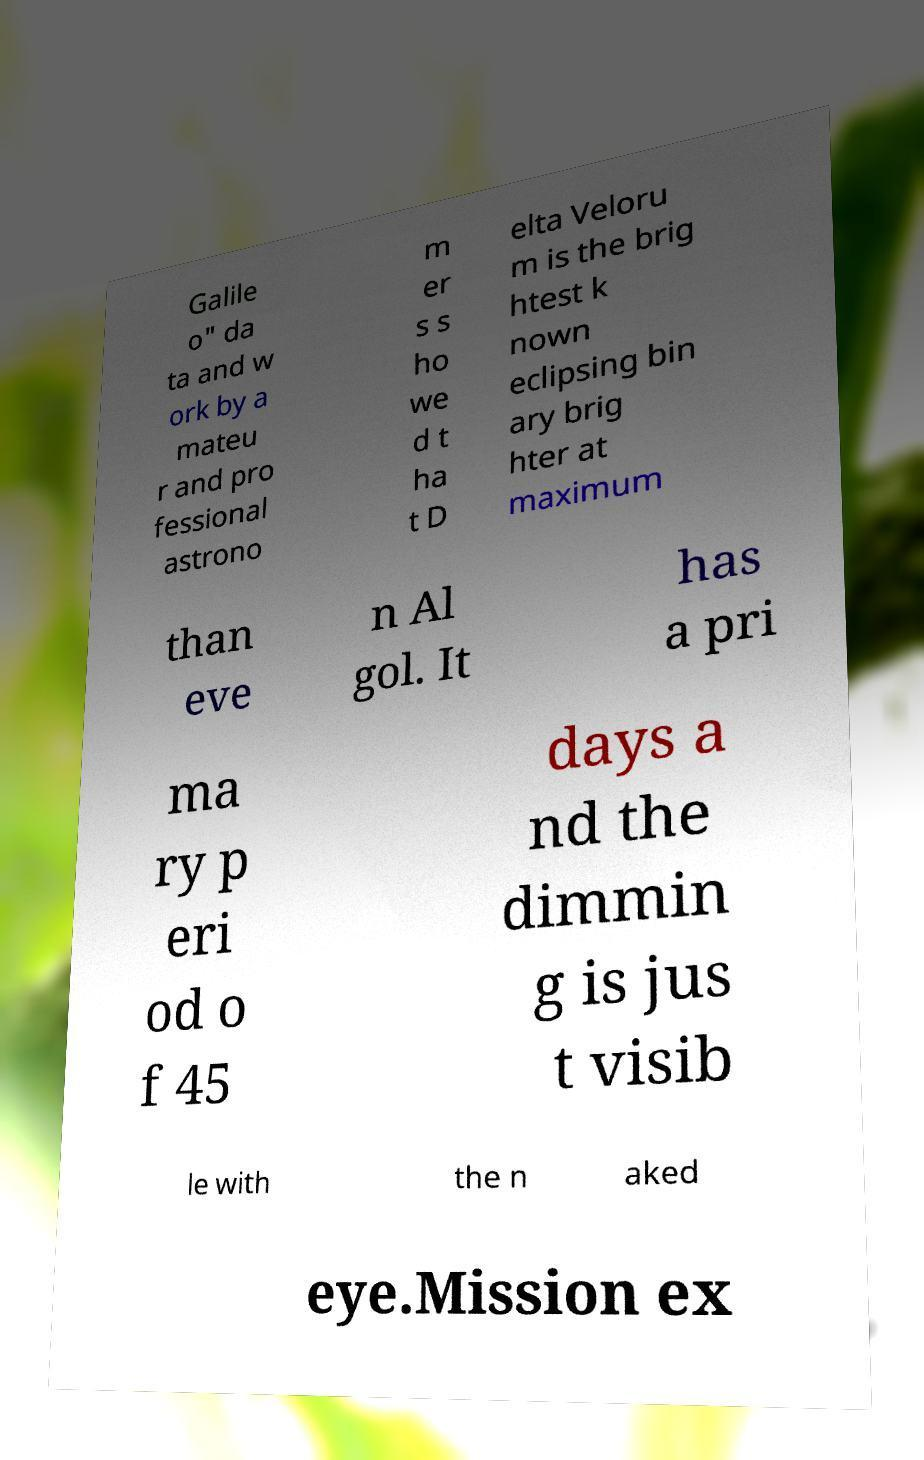Could you assist in decoding the text presented in this image and type it out clearly? Galile o" da ta and w ork by a mateu r and pro fessional astrono m er s s ho we d t ha t D elta Veloru m is the brig htest k nown eclipsing bin ary brig hter at maximum than eve n Al gol. It has a pri ma ry p eri od o f 45 days a nd the dimmin g is jus t visib le with the n aked eye.Mission ex 